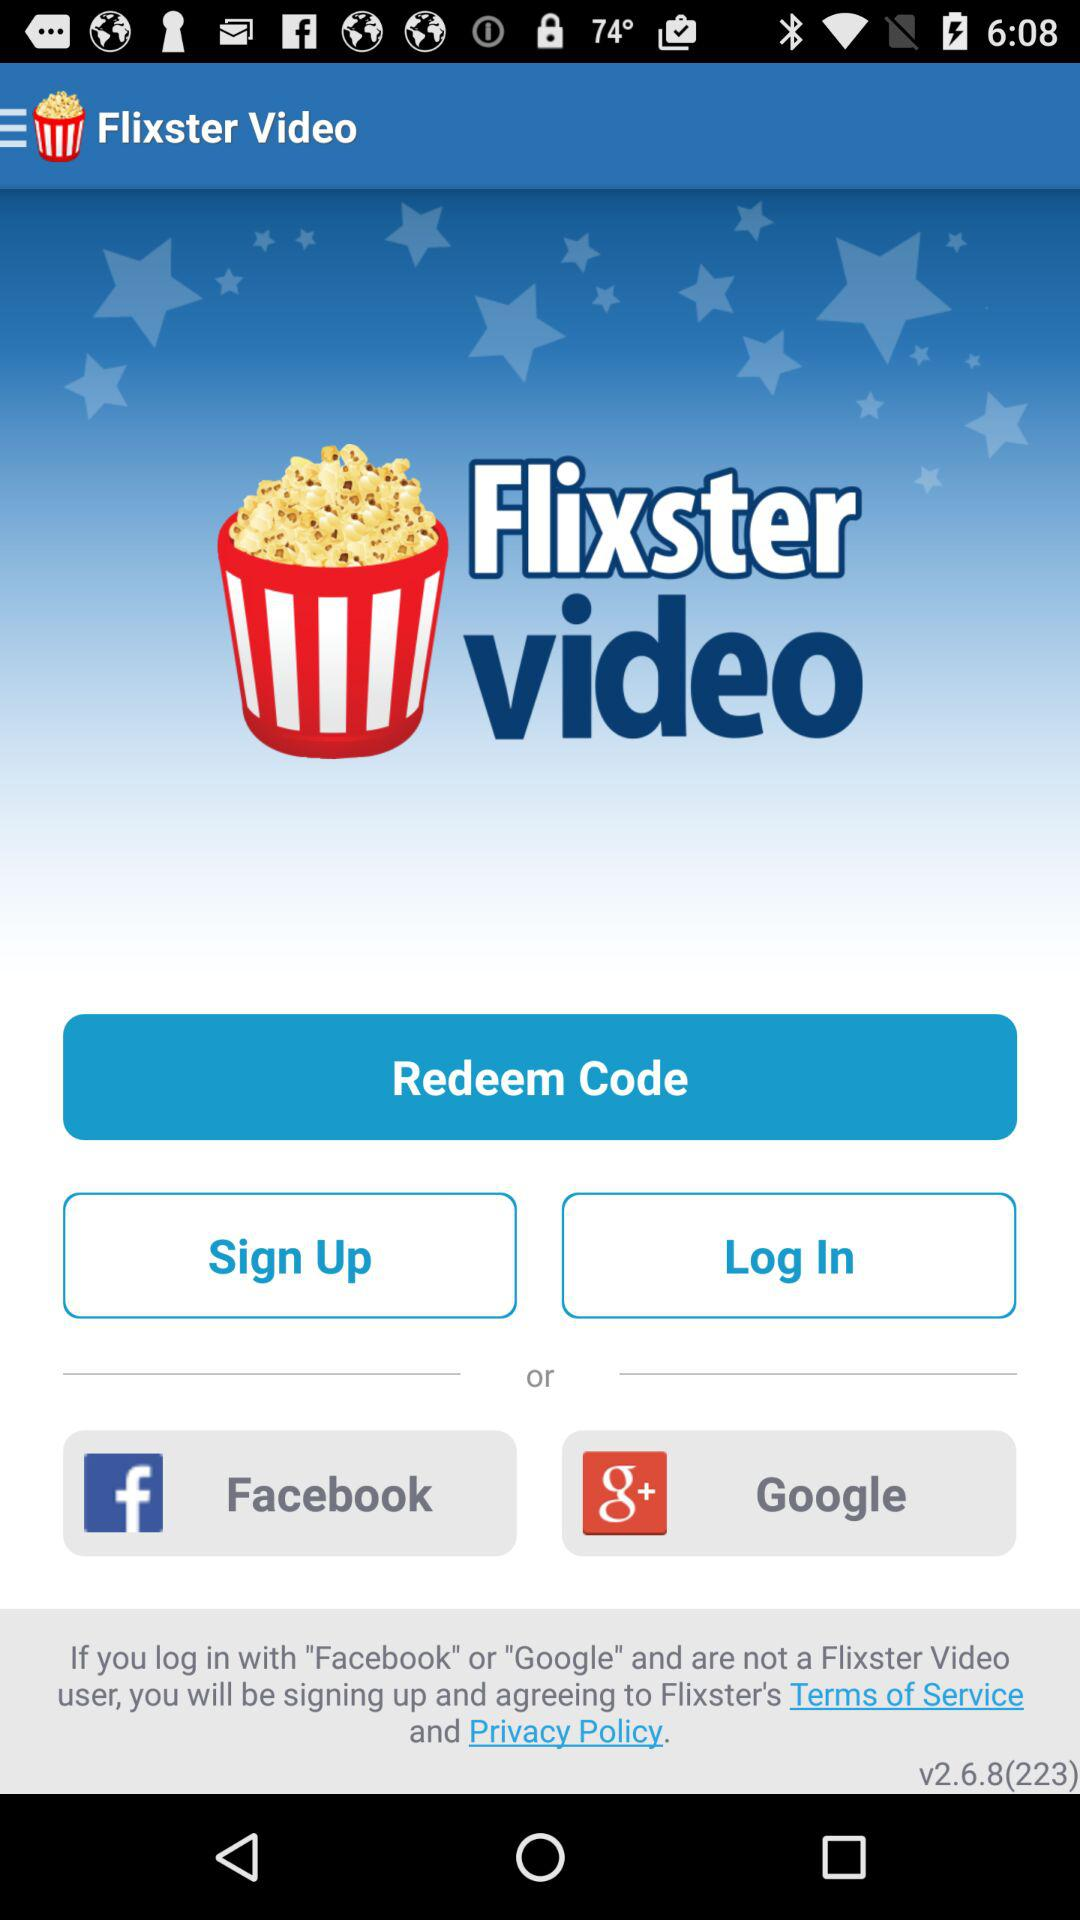What accounts can I use to log in? You can log in with "Facebook" and "Google". 